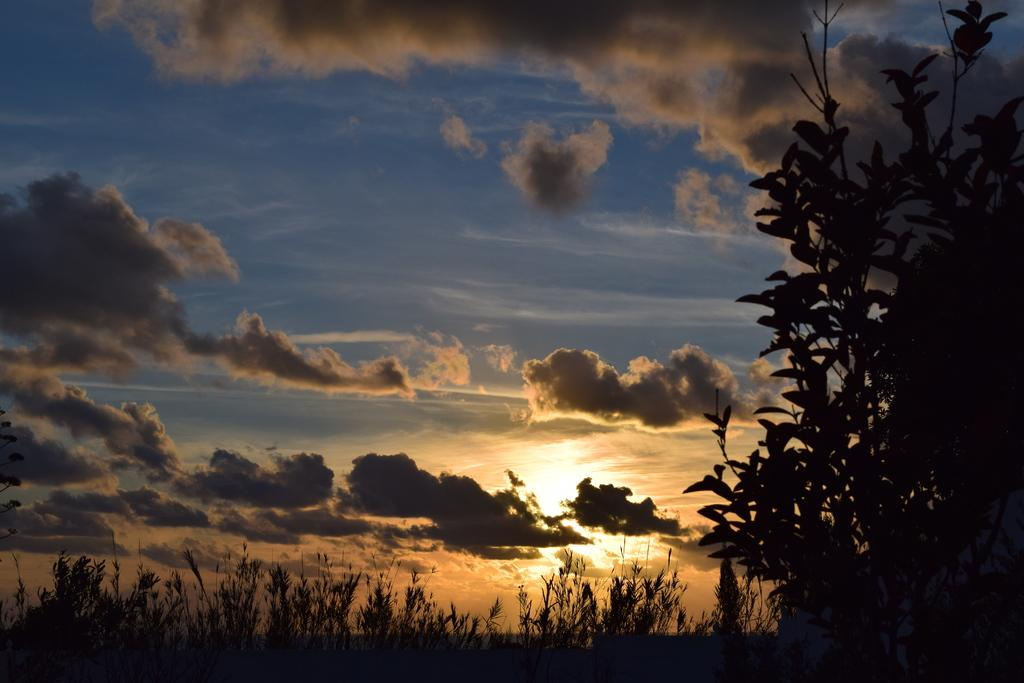What can be seen in the sky in the image? The sky is visible in the image, and there are clouds in the sky. What celestial body is visible in the image? The sun is visible in the image. What type of vegetation can be seen in the image? There are plants and trees in the image. How many straws are being used by the cow in the image? There is no cow or straw present in the image. 